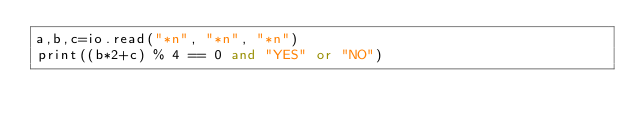<code> <loc_0><loc_0><loc_500><loc_500><_Lua_>a,b,c=io.read("*n", "*n", "*n")
print((b*2+c) % 4 == 0 and "YES" or "NO")</code> 